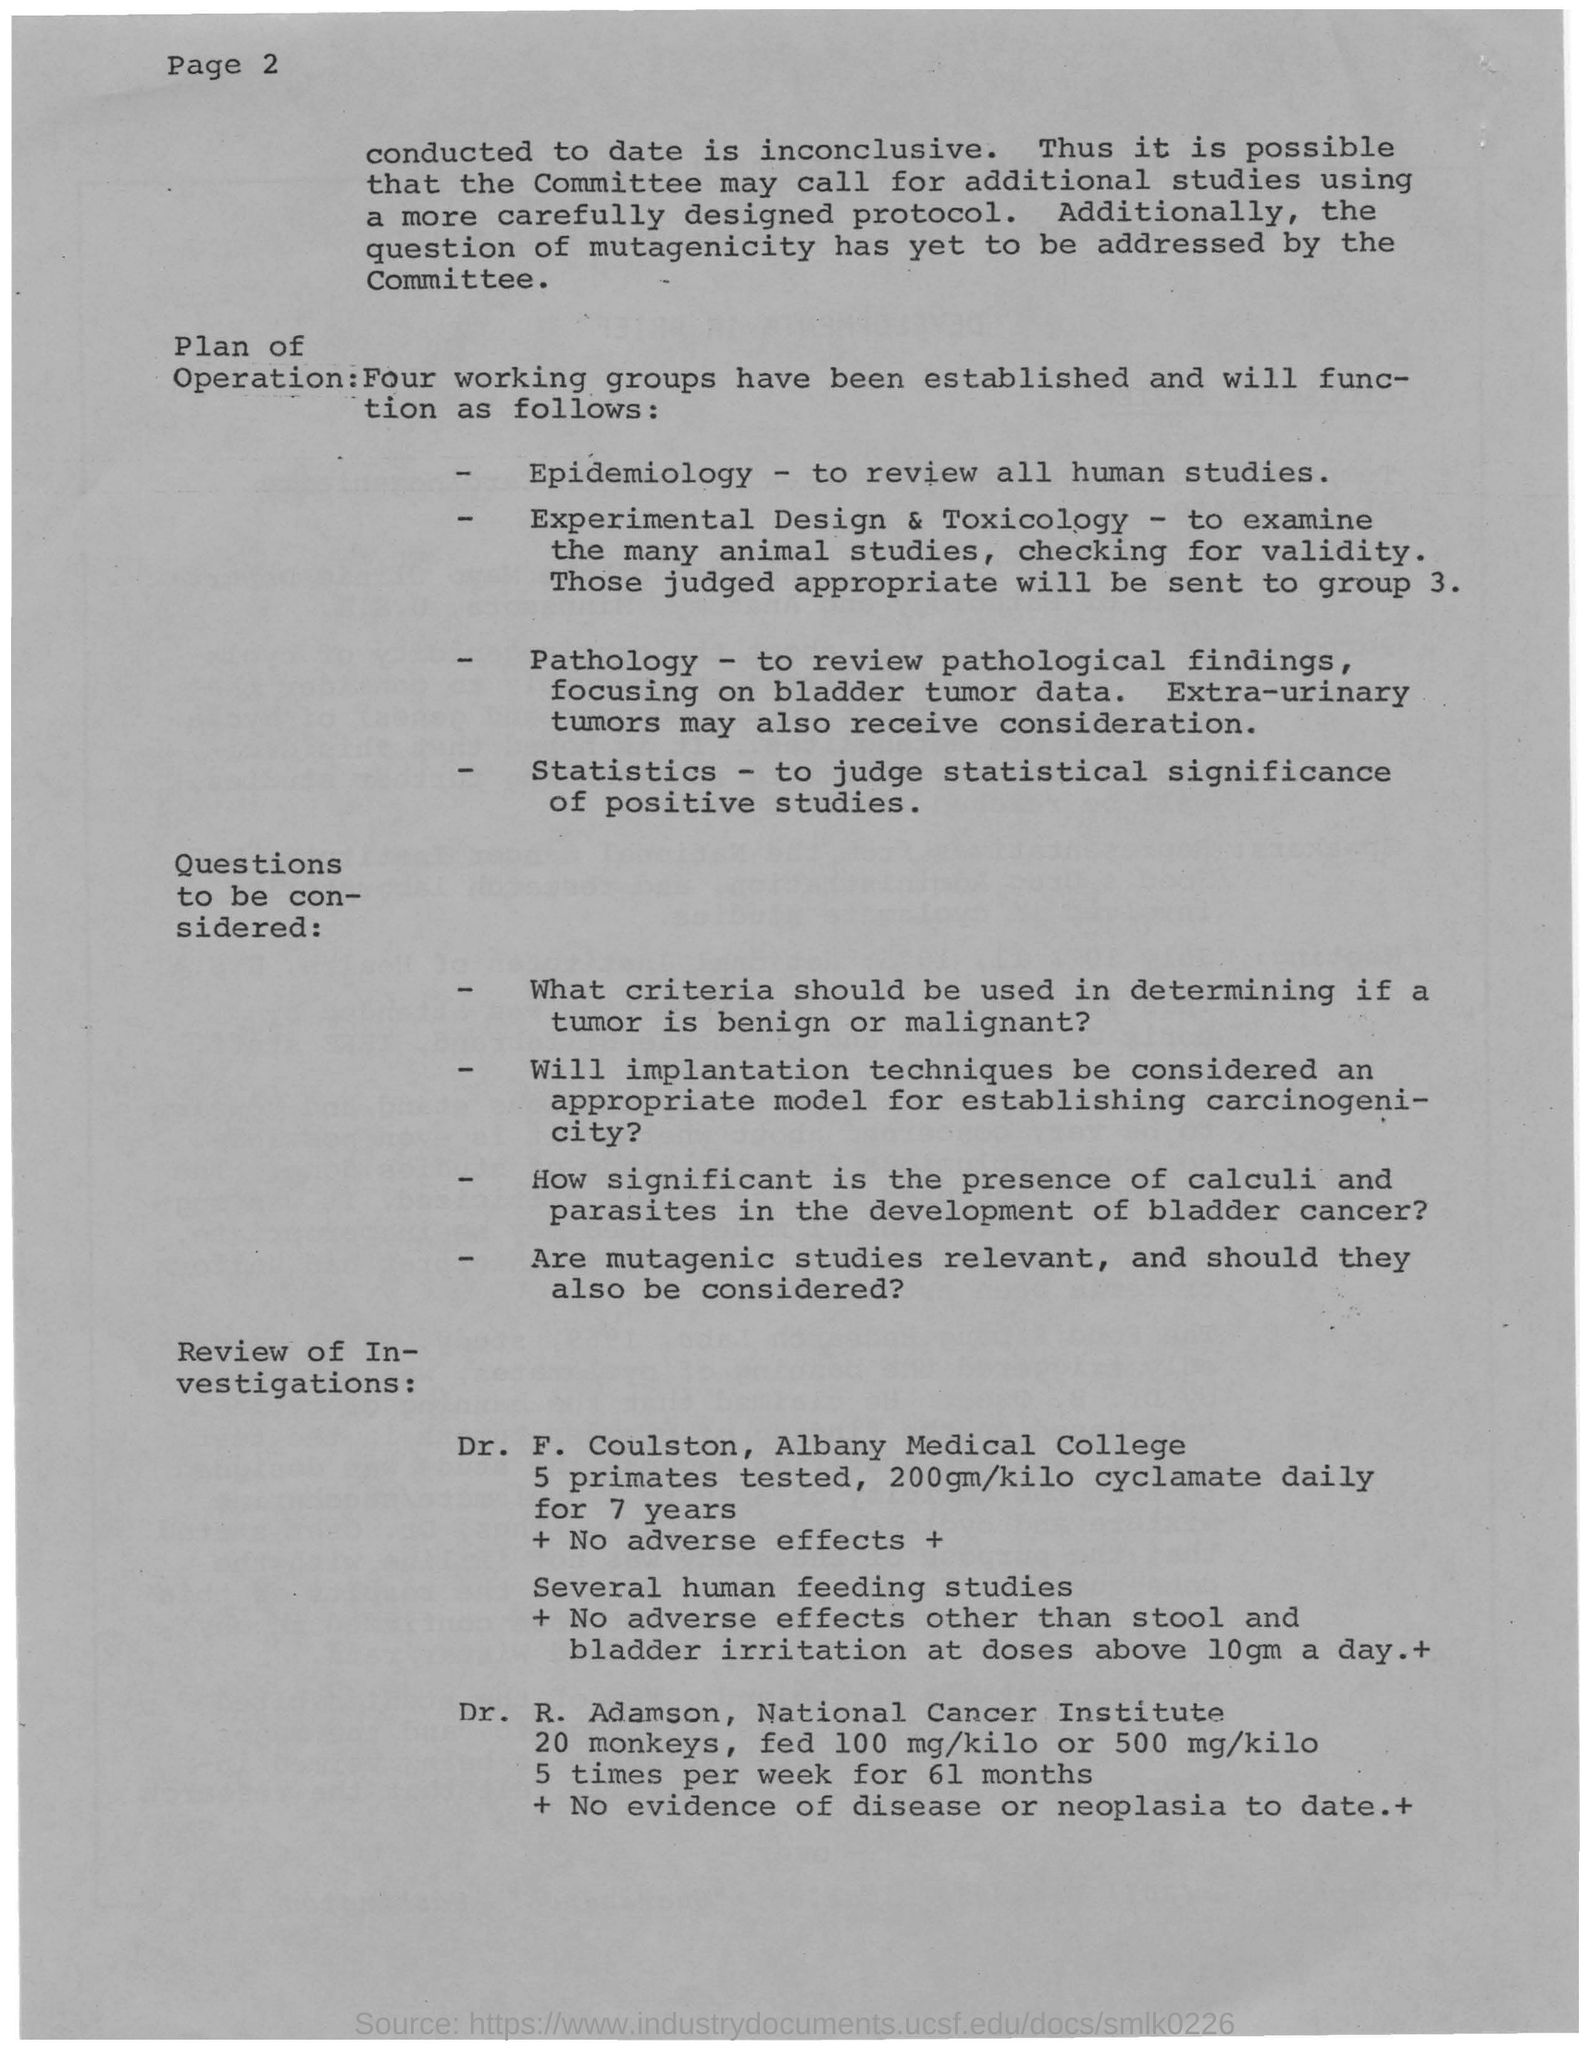What is the operation of Epidemiology?
Your answer should be compact. To review all human studies. How many primates were tested by Dr. F. Coulston?
Your answer should be compact. 5. How much of cyclamate was given to the primates daily for 7 years?
Provide a succinct answer. 200gm/kilo. 